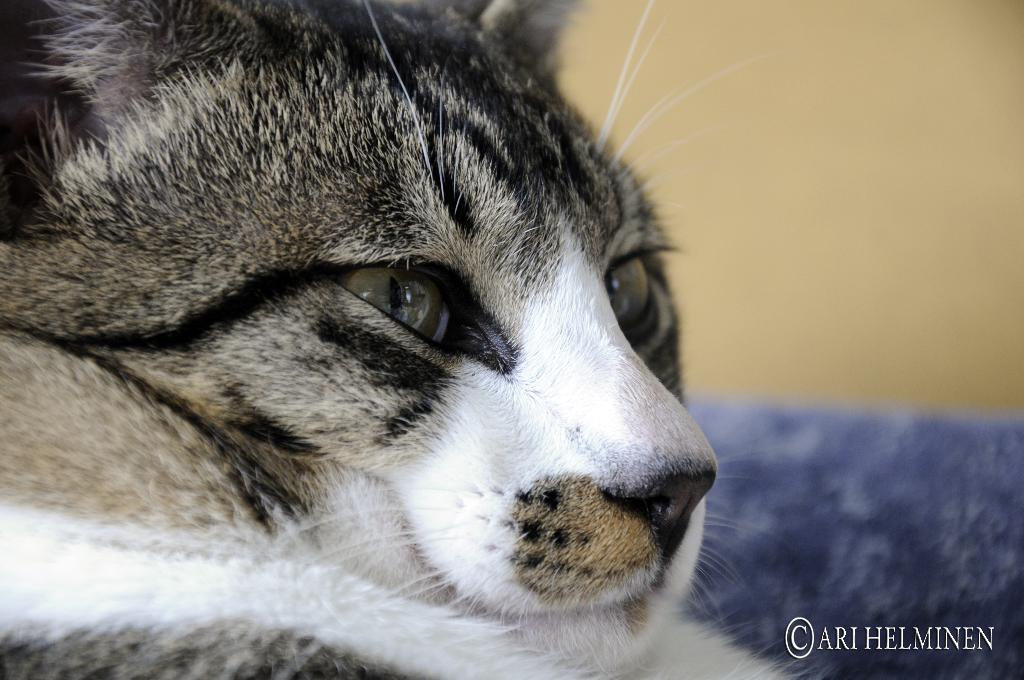In one or two sentences, can you explain what this image depicts? In this image I can see the cat in black and white color. Background is in cream and blue color. 